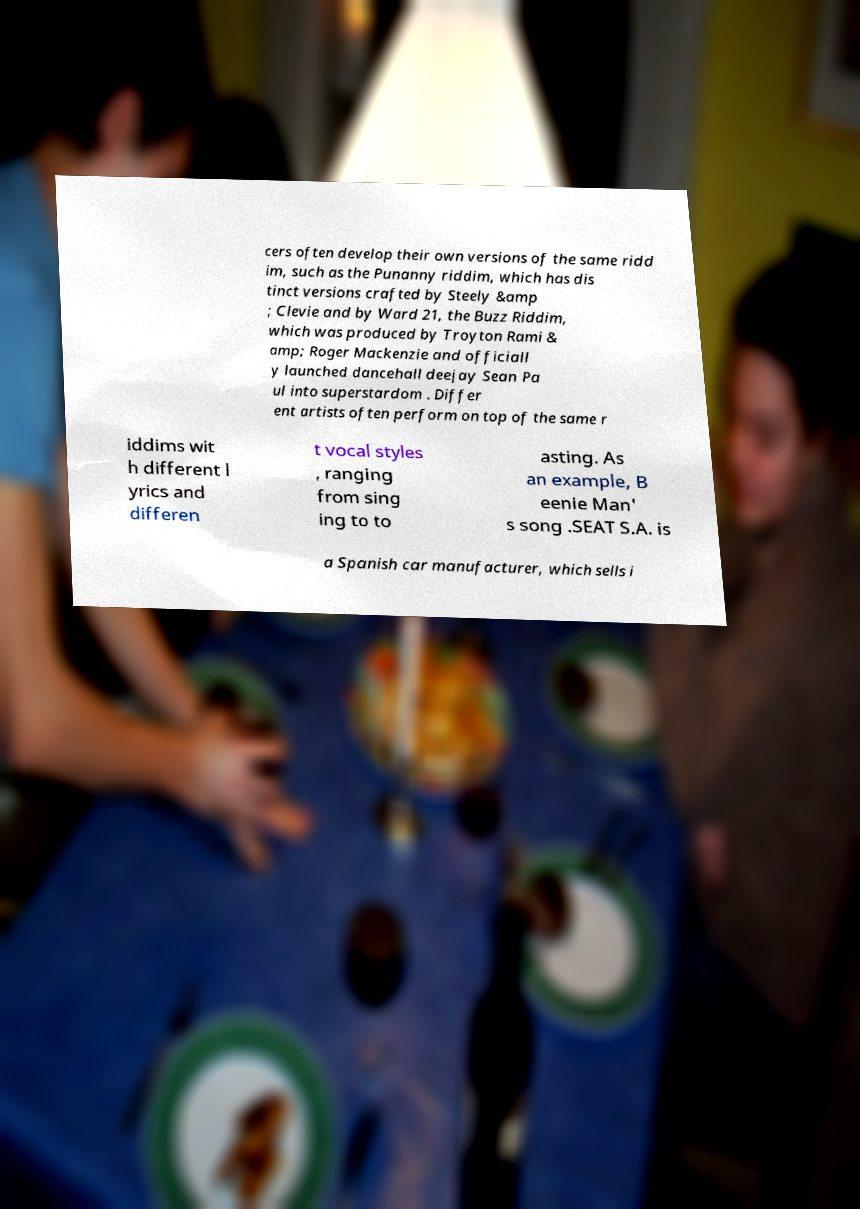For documentation purposes, I need the text within this image transcribed. Could you provide that? cers often develop their own versions of the same ridd im, such as the Punanny riddim, which has dis tinct versions crafted by Steely &amp ; Clevie and by Ward 21, the Buzz Riddim, which was produced by Troyton Rami & amp; Roger Mackenzie and officiall y launched dancehall deejay Sean Pa ul into superstardom . Differ ent artists often perform on top of the same r iddims wit h different l yrics and differen t vocal styles , ranging from sing ing to to asting. As an example, B eenie Man' s song .SEAT S.A. is a Spanish car manufacturer, which sells i 